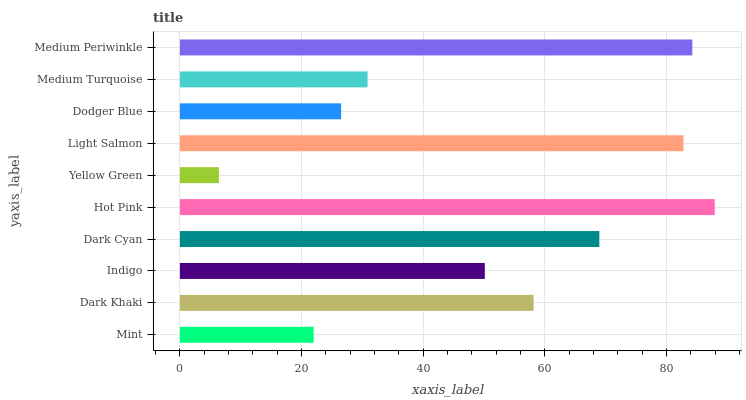Is Yellow Green the minimum?
Answer yes or no. Yes. Is Hot Pink the maximum?
Answer yes or no. Yes. Is Dark Khaki the minimum?
Answer yes or no. No. Is Dark Khaki the maximum?
Answer yes or no. No. Is Dark Khaki greater than Mint?
Answer yes or no. Yes. Is Mint less than Dark Khaki?
Answer yes or no. Yes. Is Mint greater than Dark Khaki?
Answer yes or no. No. Is Dark Khaki less than Mint?
Answer yes or no. No. Is Dark Khaki the high median?
Answer yes or no. Yes. Is Indigo the low median?
Answer yes or no. Yes. Is Indigo the high median?
Answer yes or no. No. Is Medium Periwinkle the low median?
Answer yes or no. No. 